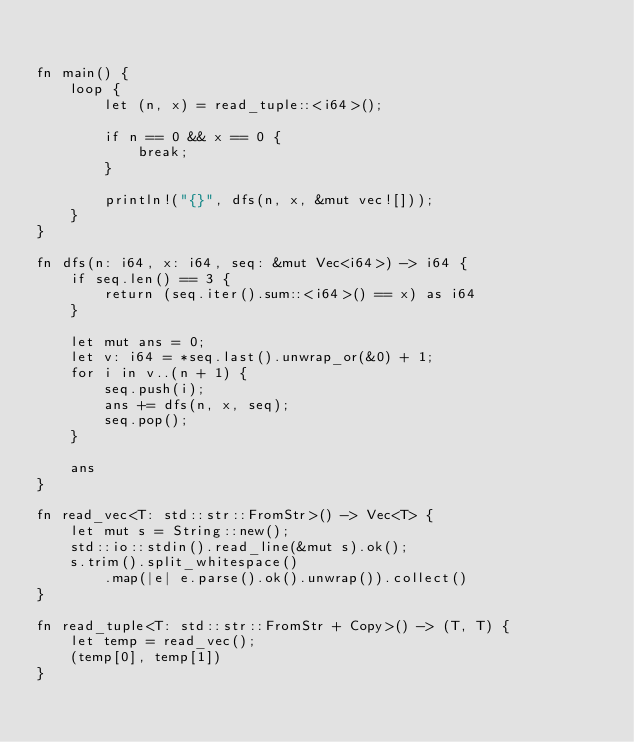Convert code to text. <code><loc_0><loc_0><loc_500><loc_500><_Rust_>

fn main() {
    loop {
        let (n, x) = read_tuple::<i64>();

        if n == 0 && x == 0 {
            break;
        }

        println!("{}", dfs(n, x, &mut vec![]));
    }
}

fn dfs(n: i64, x: i64, seq: &mut Vec<i64>) -> i64 {
    if seq.len() == 3 {
        return (seq.iter().sum::<i64>() == x) as i64 
    }

    let mut ans = 0;
    let v: i64 = *seq.last().unwrap_or(&0) + 1;
    for i in v..(n + 1) {
        seq.push(i);
        ans += dfs(n, x, seq);
        seq.pop();
    }

    ans
}

fn read_vec<T: std::str::FromStr>() -> Vec<T> {
    let mut s = String::new();
    std::io::stdin().read_line(&mut s).ok();
    s.trim().split_whitespace()
        .map(|e| e.parse().ok().unwrap()).collect()
}

fn read_tuple<T: std::str::FromStr + Copy>() -> (T, T) {
    let temp = read_vec();
    (temp[0], temp[1])
}

</code> 